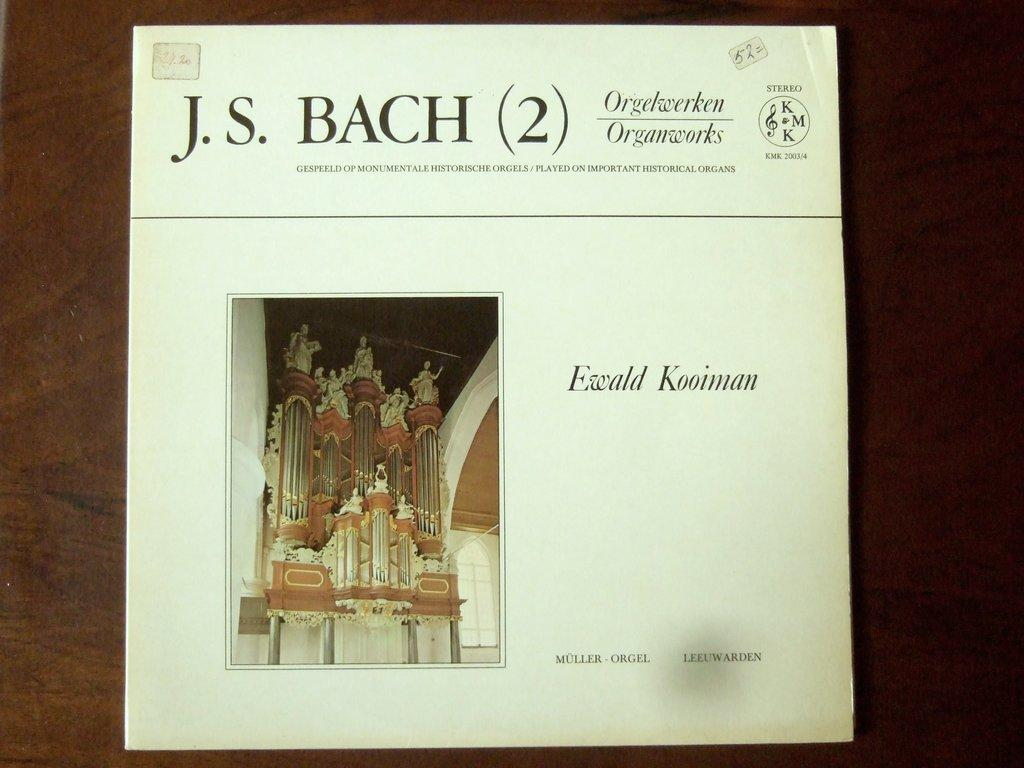<image>
Describe the image concisely. A program shows a piece of music written by composer J.S. Bach. 